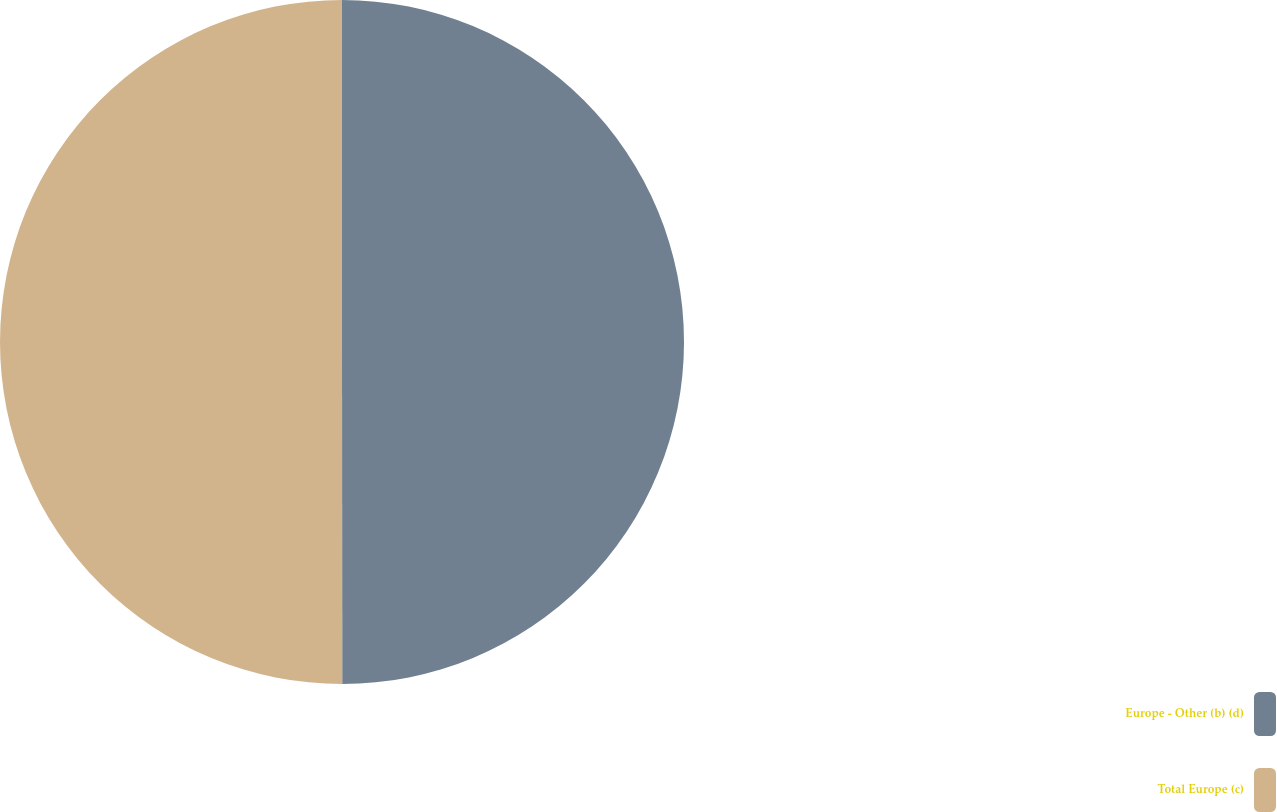Convert chart to OTSL. <chart><loc_0><loc_0><loc_500><loc_500><pie_chart><fcel>Europe - Other (b) (d)<fcel>Total Europe (c)<nl><fcel>49.99%<fcel>50.01%<nl></chart> 